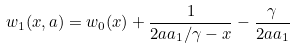Convert formula to latex. <formula><loc_0><loc_0><loc_500><loc_500>w _ { 1 } ( x , a ) = w _ { 0 } ( x ) + \frac { 1 } { 2 a a _ { 1 } / \gamma - x } - \frac { \gamma } { 2 a a _ { 1 } }</formula> 